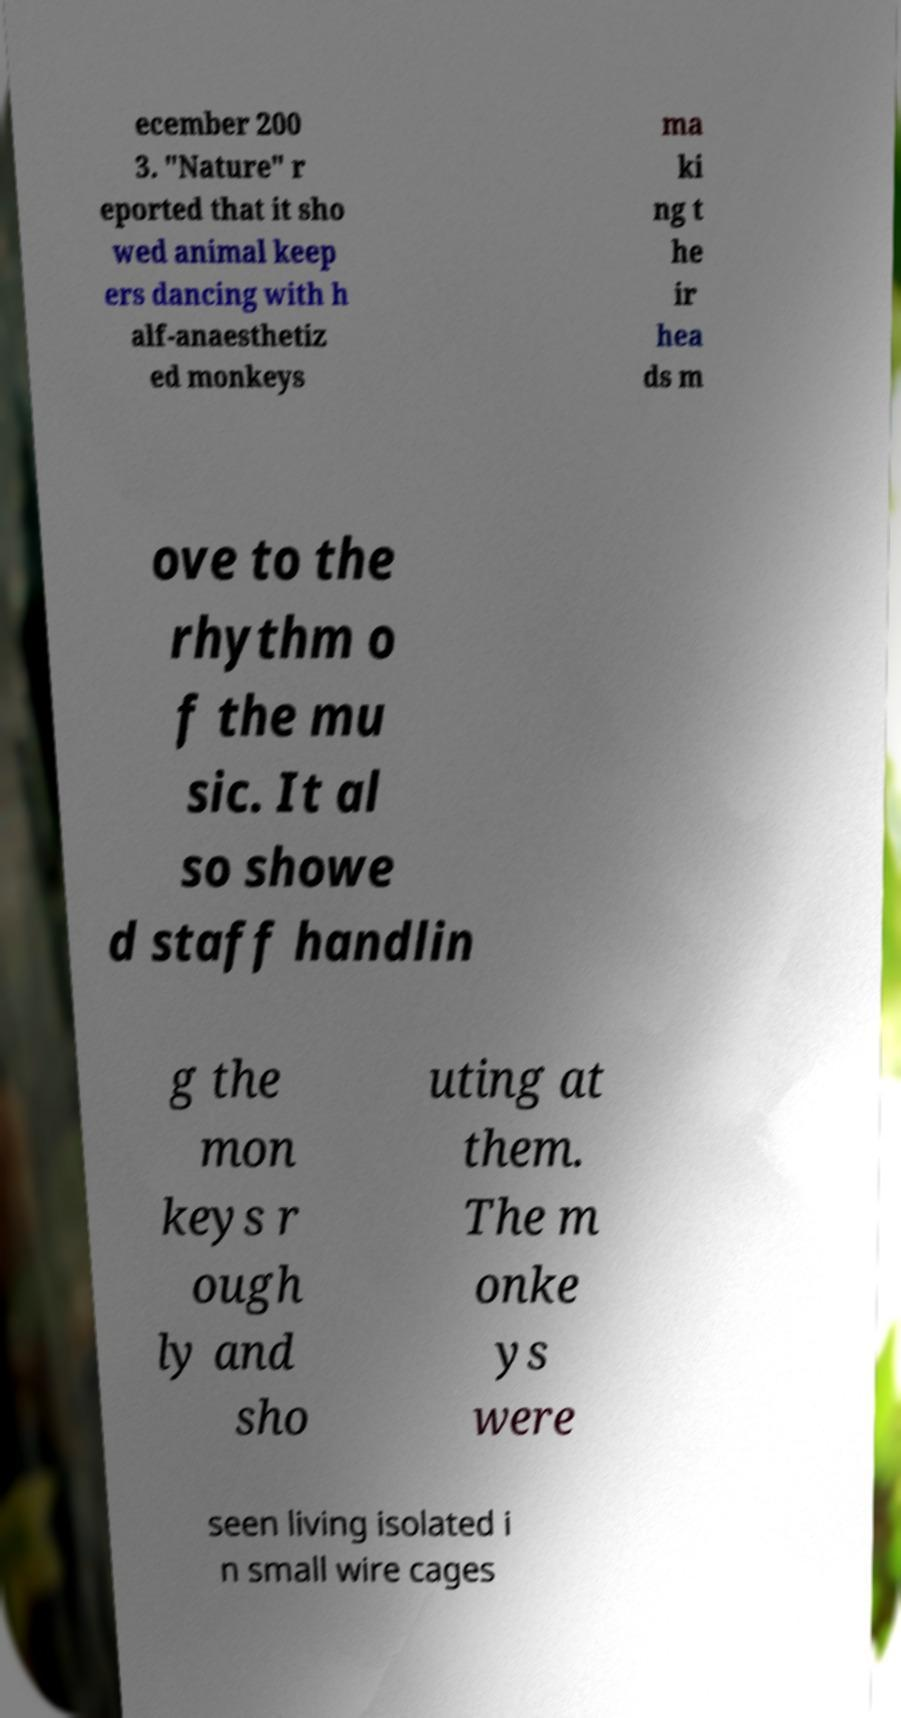Can you accurately transcribe the text from the provided image for me? ecember 200 3. "Nature" r eported that it sho wed animal keep ers dancing with h alf-anaesthetiz ed monkeys ma ki ng t he ir hea ds m ove to the rhythm o f the mu sic. It al so showe d staff handlin g the mon keys r ough ly and sho uting at them. The m onke ys were seen living isolated i n small wire cages 